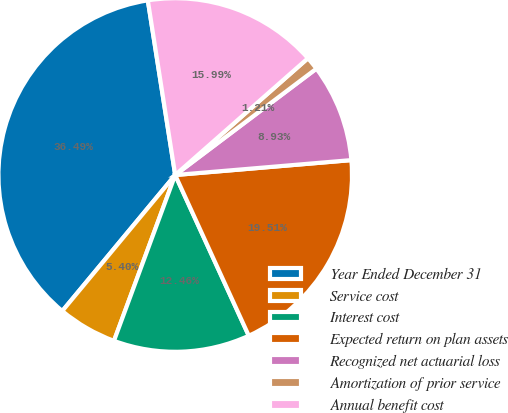Convert chart to OTSL. <chart><loc_0><loc_0><loc_500><loc_500><pie_chart><fcel>Year Ended December 31<fcel>Service cost<fcel>Interest cost<fcel>Expected return on plan assets<fcel>Recognized net actuarial loss<fcel>Amortization of prior service<fcel>Annual benefit cost<nl><fcel>36.49%<fcel>5.4%<fcel>12.46%<fcel>19.51%<fcel>8.93%<fcel>1.21%<fcel>15.99%<nl></chart> 